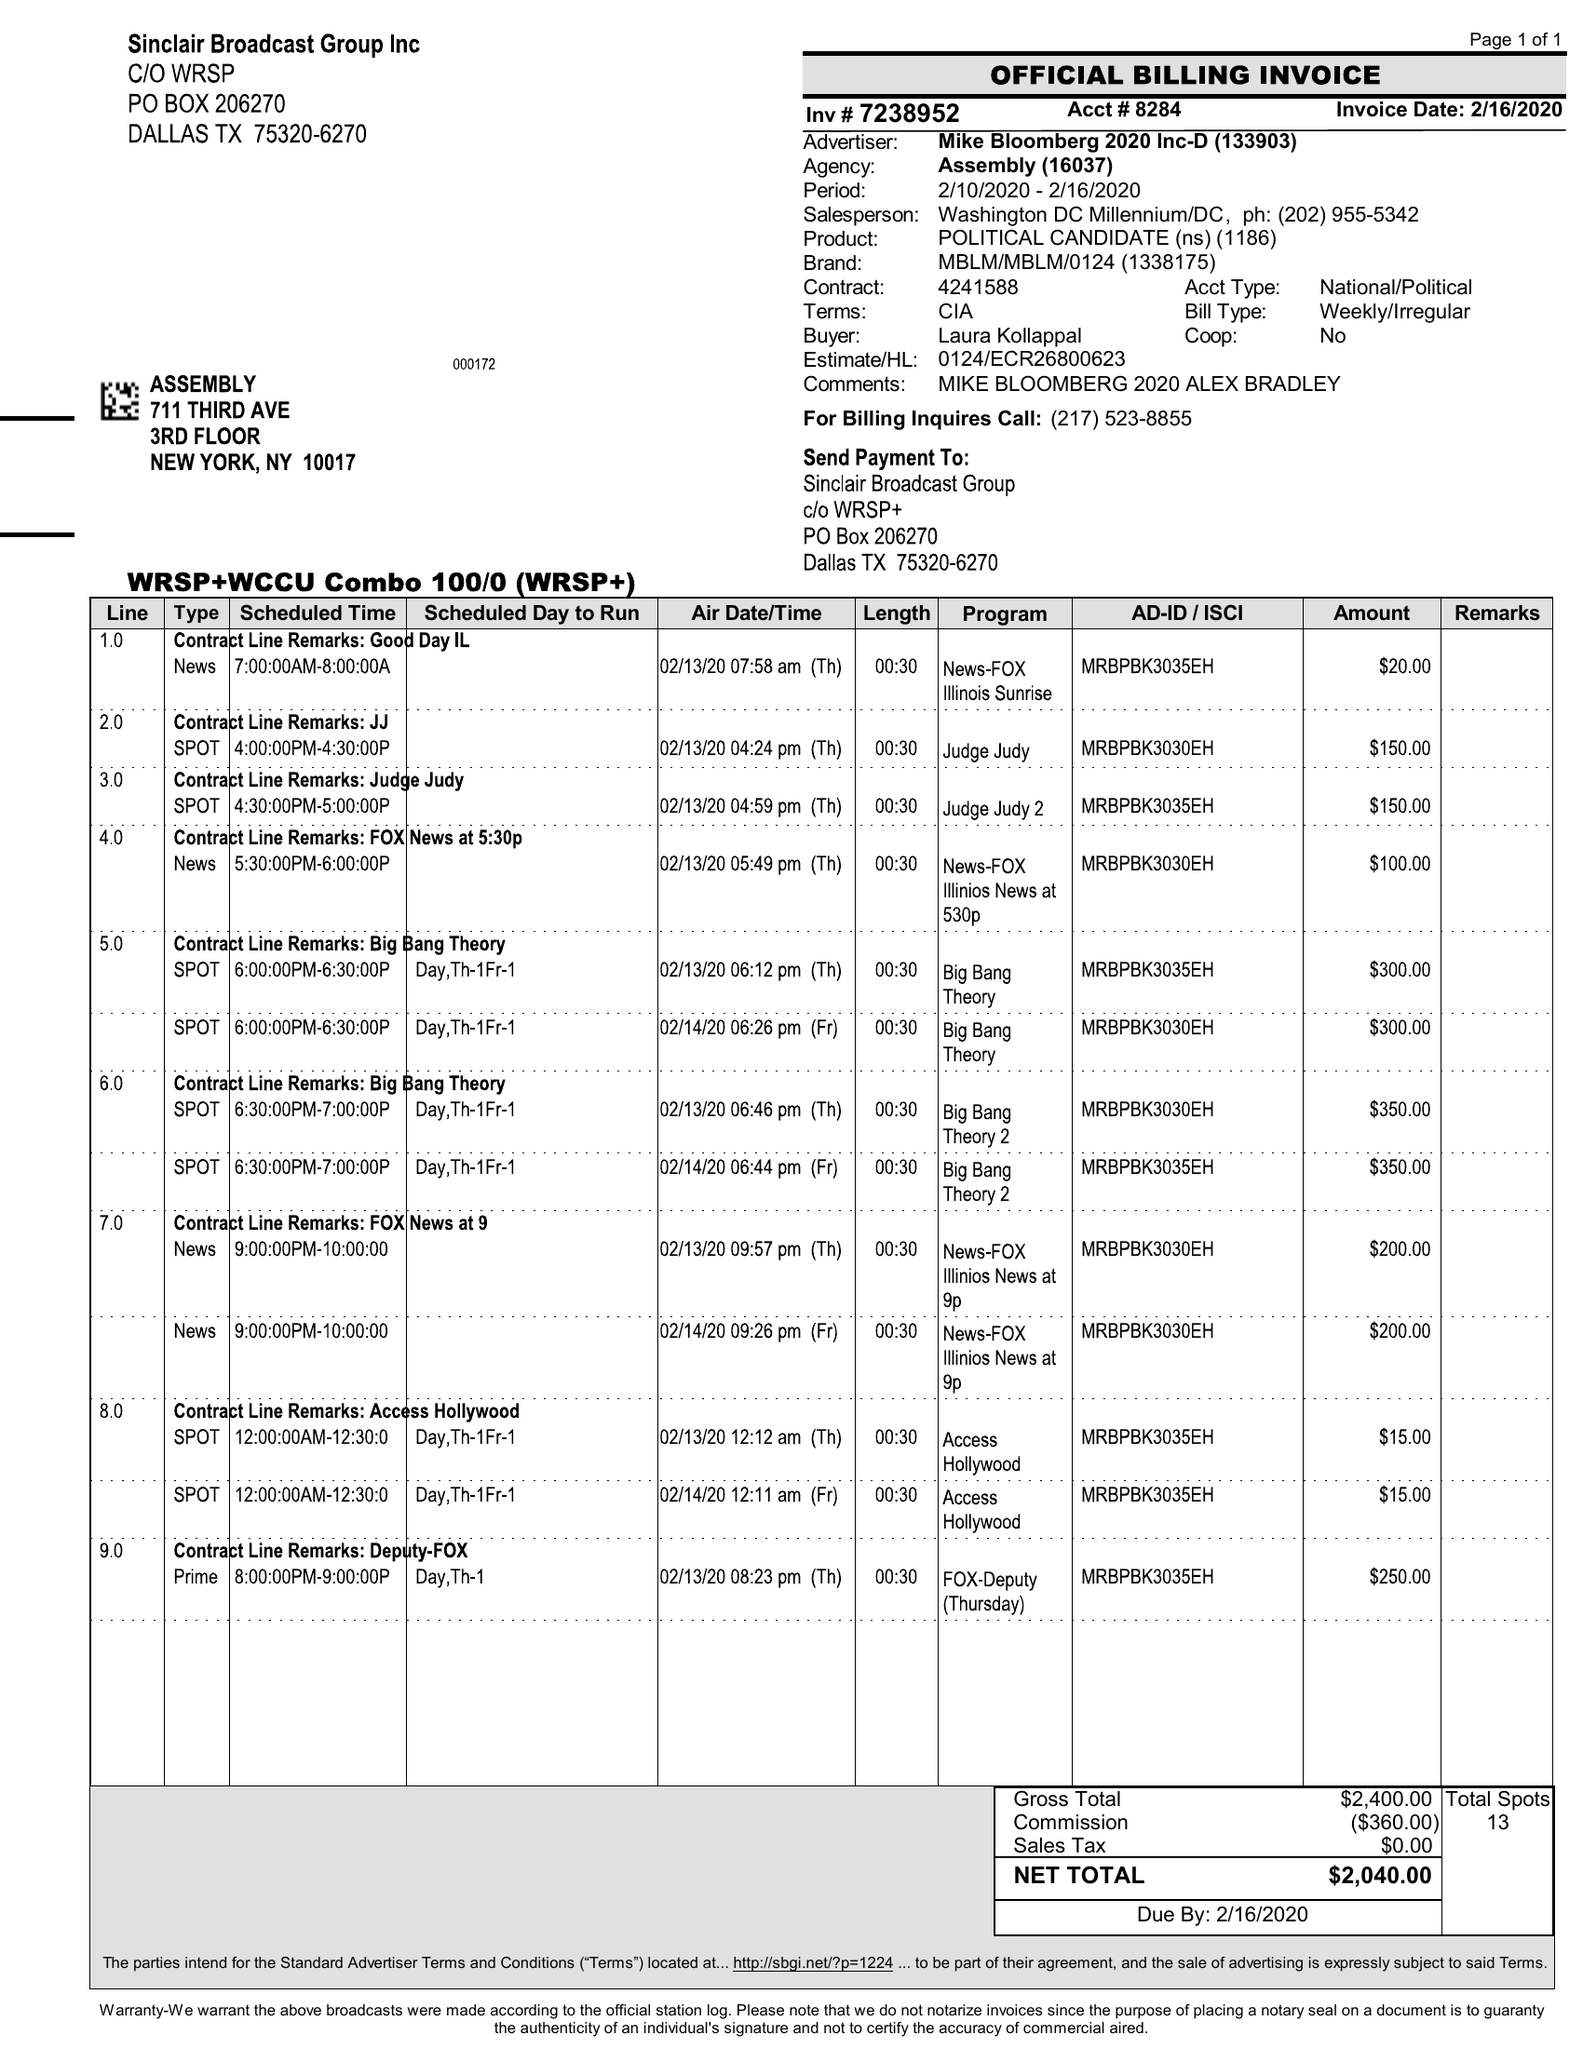What is the value for the contract_num?
Answer the question using a single word or phrase. 7238952 